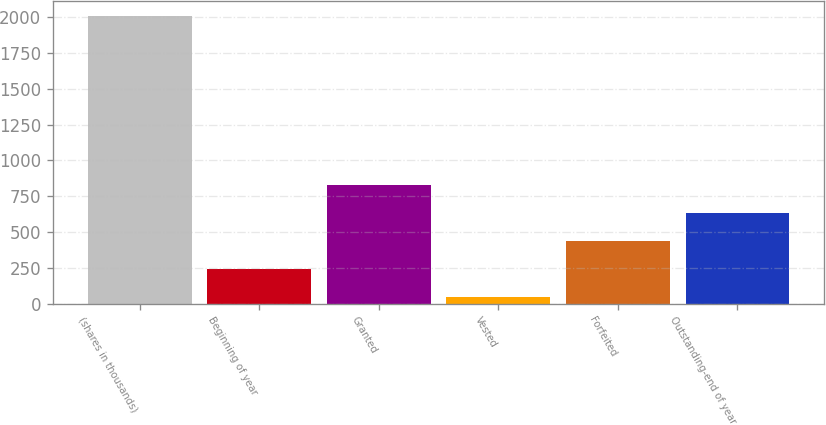Convert chart. <chart><loc_0><loc_0><loc_500><loc_500><bar_chart><fcel>(shares in thousands)<fcel>Beginning of year<fcel>Granted<fcel>Vested<fcel>Forfeited<fcel>Outstanding-end of year<nl><fcel>2012<fcel>239.74<fcel>830.5<fcel>42.82<fcel>436.66<fcel>633.58<nl></chart> 